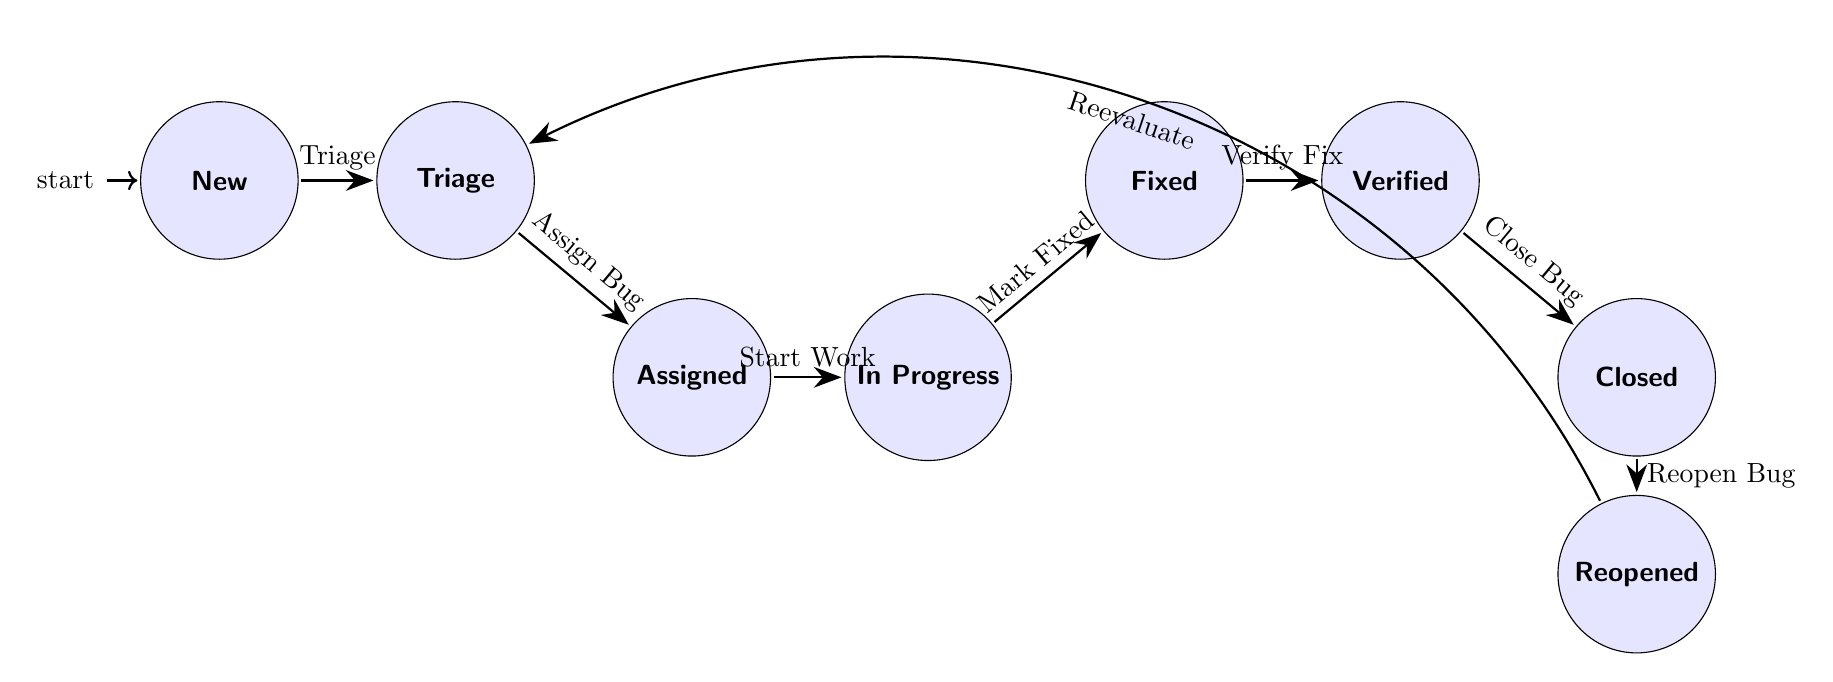What is the initial state of the bug lifecycle? The initial state, as indicated by the label "initial," is the first node in the diagram. It shows that the bug starts in the "New" state.
Answer: New How many states are there in the bug lifecycle? By counting the nodes listed in the diagram, we find a total of eight states: New, Triage, Assigned, In Progress, Fixed, Verified, Closed, and Reopened.
Answer: Eight What happens after the "Fixed" state? Following the "Fixed" state, the next state is "Verified," as shown by the arrow indicating the transition from Fixed to Verified.
Answer: Verified Which state does the "Reopen Bug" transition return to? The "Reopen Bug" transition leads from the "Closed" state to the "Reopened" state, indicating that when a bug is reopened, it returns to being categorized as Reopened.
Answer: Reopened What transition occurs after the "Assigned" state? After the "Assigned" state, the next transition is "Start Work," leading to the "In Progress" state. This shows that after assignment, work on the bug begins.
Answer: In Progress What is the final state if all transitions are followed without reopening? Starting from "New" and following the transitions through Triage, Assigned, In Progress, Fixed, and Verified, the final state reached without reopening is "Closed."
Answer: Closed How many transitions are there in total? The number of transitions can be counted from the listed transitions in the diagram. There are eight transitions: Triage, Assign Bug, Start Work, Mark Fixed, Verify Fix, Close Bug, Reopen Bug, and Reevaluate.
Answer: Eight What is the transition that moves a bug from "Reopened" back to "Triage"? The transition that moves a bug from "Reopened" back to "Triage" is labeled "Reevaluate," as indicated by the arrow returning to the Triage state.
Answer: Reevaluate What does the "Mark Fixed" transition signify? The "Mark Fixed" transition indicates the point in the bug lifecycle where the developer considers the bug resolved, transitioning the state from "In Progress" to "Fixed."
Answer: Fixed 